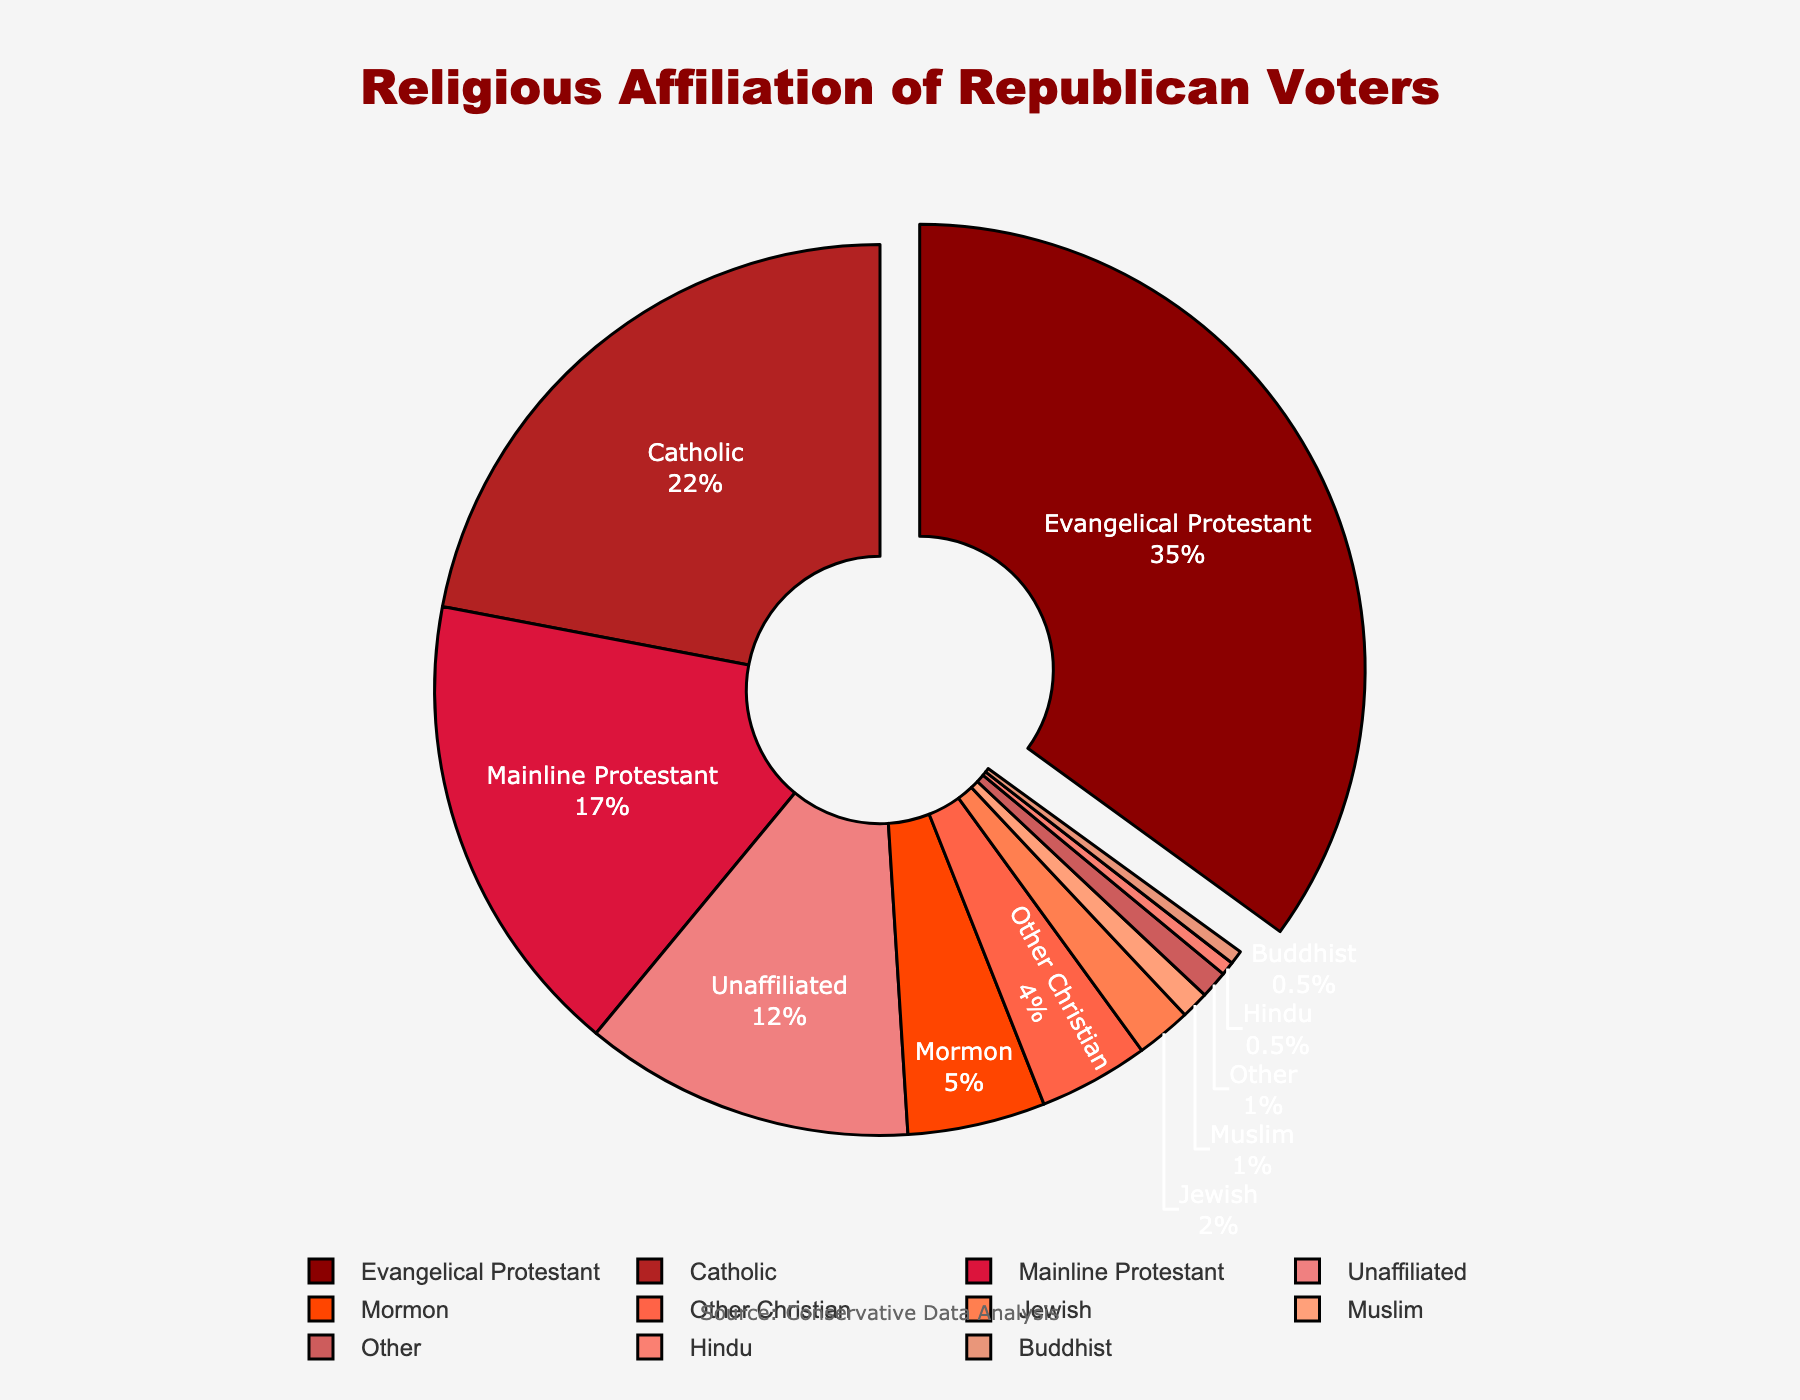What's the most common religious affiliation among Republican voters? The pie chart shows percentages for different religious affiliations. The largest segment is Evangelical Protestant, which is 35% of the total.
Answer: Evangelical Protestant Which two religious affiliations combined make up the smallest percentage? The pie chart's smallest segments are Hindu (0.5%) and Buddhist (0.5%). Together, they sum to 1%.
Answer: Hindu and Buddhist How much larger is the percentage of Evangelical Protestant voters compared to Mainline Protestant voters? The pie chart shows Evangelical Protestant at 35% and Mainline Protestant at 17%. Subtracting these gives 35 - 17 = 18%.
Answer: 18% Which religious affiliation is represented by the color that has the darkest red hue? The darkest red color represents Evangelical Protestant, which is the largest segment at 35%.
Answer: Evangelical Protestant Is the 'Unaffiliated' group larger or smaller than the 'Catholic' group? The pie chart shows 'Unaffiliated' at 12% and 'Catholic' at 22%. Since 12 is less than 22, the 'Unaffiliated' group is smaller.
Answer: Smaller What percentage of Republican voters identify with religious affiliations other than Protestant categories (Evangelical, Mainline, Other Christian)? Summing non-Protestant categories: Catholic (22%) + Mormon (5%) + Jewish (2%) + Muslim (1%) + Hindu (0.5%) + Buddhist (0.5%) + Unaffiliated (12%) + Other (1%) = 44%.
Answer: 44% Which category has a percentage closest to the 'Jewish' group? The pie chart shows Jewish at 2% and Other at 1%, Muslim at 1%, and smaller groups like Hindu and Buddhist at 0.5%. Jewish is closest to Muslim and Other.
Answer: Muslim and Other What is the total percentage for all Christian affiliations excluding 'Mormon'? Summing Christian affiliations excluding Mormon: Evangelical Protestant (35%) + Catholic (22%) + Mainline Protestant (17%) + Other Christian (4%) = 78%.
Answer: 78% How does the percentage of 'Evangelical Protestant' compare to the combined percentage of 'Jewish', 'Muslim', 'Hindu', and 'Buddhist'? Summing Jewish (2%), Muslim (1%), Hindu (0.5%), and Buddhist (0.5%) results in 4%. Comparing this to Evangelical Protestant at 35%, 35% is much larger.
Answer: Much larger What is the average percentage for Protestant groups (Evangelical, Mainline, Other Christian)? Summing Protestant groups: Evangelical (35%) + Mainline (17%) + Other Christian (4%) = 56%. Divide by the number of groups (3), so 56 / 3 ≈ 18.67%.
Answer: 18.67% 